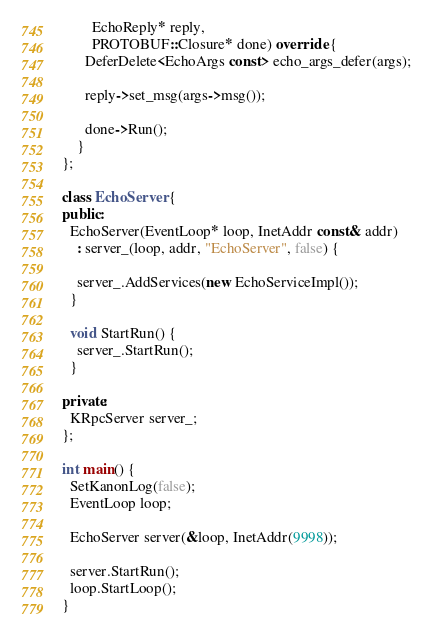Convert code to text. <code><loc_0><loc_0><loc_500><loc_500><_C++_>        EchoReply* reply,
        PROTOBUF::Closure* done) override {
      DeferDelete<EchoArgs const> echo_args_defer(args); 

      reply->set_msg(args->msg());

      done->Run();
    }
};

class EchoServer {
public:
  EchoServer(EventLoop* loop, InetAddr const& addr) 
    : server_(loop, addr, "EchoServer", false) {

    server_.AddServices(new EchoServiceImpl());
  }
  
  void StartRun() {
    server_.StartRun();
  }

private:
  KRpcServer server_;
};

int main() {
  SetKanonLog(false);
  EventLoop loop;
  
  EchoServer server(&loop, InetAddr(9998));

  server.StartRun();
  loop.StartLoop();
}
</code> 